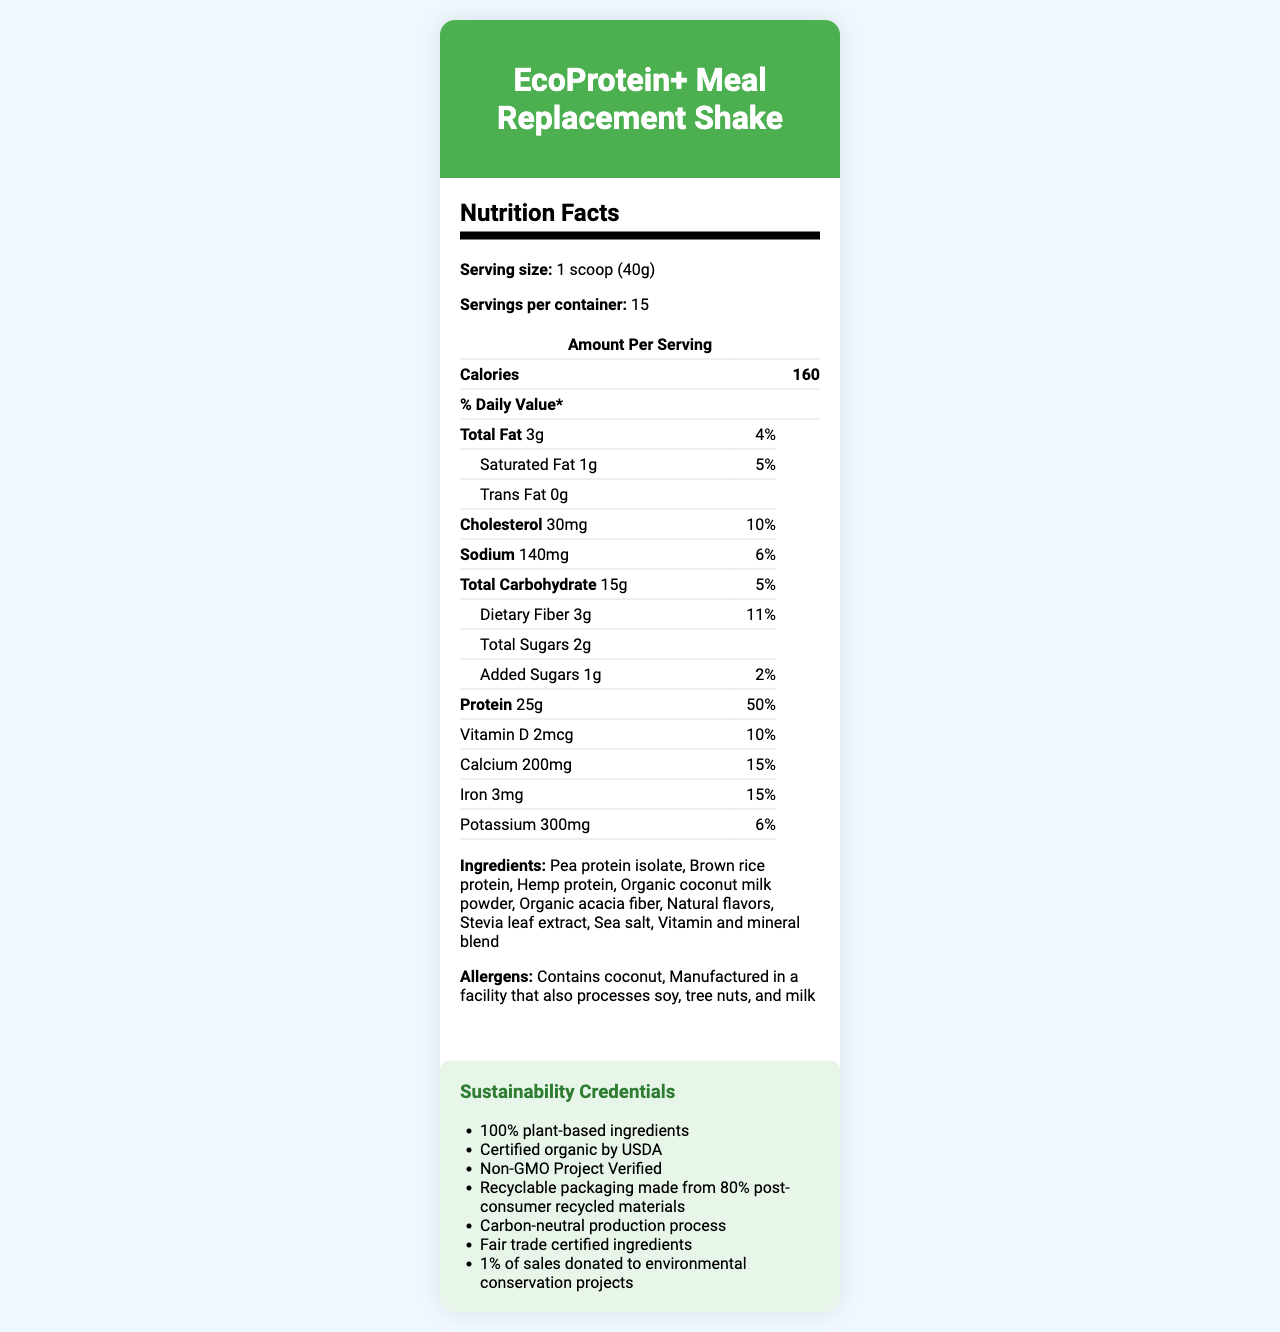who is the product intended for? The product is designed as a high-protein meal replacement shake, often targeting those looking for healthy, plant-based protein options.
Answer: Consumers seeking a high-protein, plant-based meal replacement shake how many grams of protein are in one serving? According to the Nutrition Facts, one serving size contains 25 grams of protein.
Answer: 25g how many calories are in a single serving? The document specifies that a single serving size of 1 scoop (40g) contains 160 calories.
Answer: 160 does the shake contain any sugar? The shake contains 2 grams of total sugars, including 1 gram of added sugars per serving.
Answer: Yes what are the first three ingredients listed? The first three ingredients, as listed, are Pea protein isolate, Brown rice protein, and Hemp protein.
Answer: Pea protein isolate, Brown rice protein, Hemp protein which certification does this product hold? A. Fairtrade B. USDA Organic C. Gluten-Free D. Vegan The sustainability credentials section states that the product is certified organic by USDA.
Answer: B. USDA Organic what is the daily value percentage of dietary fiber? A. 5% B. 10% C. 11% D. 15% The document specifies that a serving contains 3 grams of dietary fiber, which corresponds to 11% of the daily value.
Answer: C. 11% is this product non-gmo? One of the sustainability credentials listed is "Non-GMO Project Verified."
Answer: Yes summarize the sustainability credentials of this product. The sustainability credentials highlight the various commitments to environmentally friendly and ethically sourced practices in the product's production and packaging.
Answer: The product features 100% plant-based ingredients, certified organic by USDA, Non-GMO Project Verified, recyclable packaging made from 80% post-consumer recycled materials, carbon-neutral production process, fair trade certified ingredients, and 1% of sales donated to environmental conservation projects. what is the main source of protein in the shake? The first ingredient listed is Pea protein isolate, indicating it is the primary protein source in the shake.
Answer: Pea protein isolate what flavorings are used in the shake? Natural flavors and Stevia leaf extract are listed in the ingredients section.
Answer: Natural flavors and Stevia leaf extract how does the protein content compare to leading competitors? The competitor comparison section mentions that the protein content is 25% higher than that of leading competitors.
Answer: 25% higher than leading competitors what is the growth rate in revenue for this product? The document mentions a revenue growth of 15% year-over-year in the financial performance section.
Answer: 15% year-over-year what are the potential regulatory risks mentioned? The investment considerations section lists potential regulatory risks related to health claims.
Answer: Health claims what is the packaging made from? The sustainability credentials section mentions that the packaging is made from 80% post-consumer recycled materials.
Answer: Recyclable packaging made from 80% post-consumer recycled materials what specific sectors of the market does this product target? The financial performance section states that the product holds an 8% market share of the meal replacement shake market.
Answer: The meal replacement shake market can the document tell me where the product is manufactured? The document does not provide any details about the manufacturing location of the product.
Answer: Not enough information 